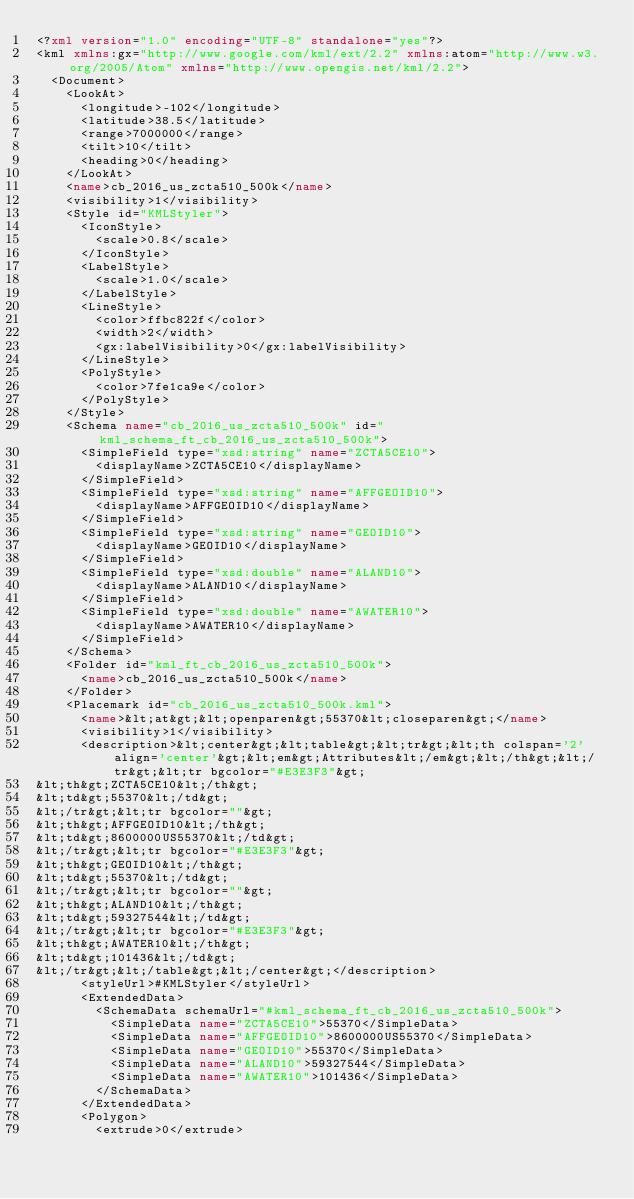<code> <loc_0><loc_0><loc_500><loc_500><_XML_><?xml version="1.0" encoding="UTF-8" standalone="yes"?>
<kml xmlns:gx="http://www.google.com/kml/ext/2.2" xmlns:atom="http://www.w3.org/2005/Atom" xmlns="http://www.opengis.net/kml/2.2">
  <Document>
    <LookAt>
      <longitude>-102</longitude>
      <latitude>38.5</latitude>
      <range>7000000</range>
      <tilt>10</tilt>
      <heading>0</heading>
    </LookAt>
    <name>cb_2016_us_zcta510_500k</name>
    <visibility>1</visibility>
    <Style id="KMLStyler">
      <IconStyle>
        <scale>0.8</scale>
      </IconStyle>
      <LabelStyle>
        <scale>1.0</scale>
      </LabelStyle>
      <LineStyle>
        <color>ffbc822f</color>
        <width>2</width>
        <gx:labelVisibility>0</gx:labelVisibility>
      </LineStyle>
      <PolyStyle>
        <color>7fe1ca9e</color>
      </PolyStyle>
    </Style>
    <Schema name="cb_2016_us_zcta510_500k" id="kml_schema_ft_cb_2016_us_zcta510_500k">
      <SimpleField type="xsd:string" name="ZCTA5CE10">
        <displayName>ZCTA5CE10</displayName>
      </SimpleField>
      <SimpleField type="xsd:string" name="AFFGEOID10">
        <displayName>AFFGEOID10</displayName>
      </SimpleField>
      <SimpleField type="xsd:string" name="GEOID10">
        <displayName>GEOID10</displayName>
      </SimpleField>
      <SimpleField type="xsd:double" name="ALAND10">
        <displayName>ALAND10</displayName>
      </SimpleField>
      <SimpleField type="xsd:double" name="AWATER10">
        <displayName>AWATER10</displayName>
      </SimpleField>
    </Schema>
    <Folder id="kml_ft_cb_2016_us_zcta510_500k">
      <name>cb_2016_us_zcta510_500k</name>
    </Folder>
    <Placemark id="cb_2016_us_zcta510_500k.kml">
      <name>&lt;at&gt;&lt;openparen&gt;55370&lt;closeparen&gt;</name>
      <visibility>1</visibility>
      <description>&lt;center&gt;&lt;table&gt;&lt;tr&gt;&lt;th colspan='2' align='center'&gt;&lt;em&gt;Attributes&lt;/em&gt;&lt;/th&gt;&lt;/tr&gt;&lt;tr bgcolor="#E3E3F3"&gt;
&lt;th&gt;ZCTA5CE10&lt;/th&gt;
&lt;td&gt;55370&lt;/td&gt;
&lt;/tr&gt;&lt;tr bgcolor=""&gt;
&lt;th&gt;AFFGEOID10&lt;/th&gt;
&lt;td&gt;8600000US55370&lt;/td&gt;
&lt;/tr&gt;&lt;tr bgcolor="#E3E3F3"&gt;
&lt;th&gt;GEOID10&lt;/th&gt;
&lt;td&gt;55370&lt;/td&gt;
&lt;/tr&gt;&lt;tr bgcolor=""&gt;
&lt;th&gt;ALAND10&lt;/th&gt;
&lt;td&gt;59327544&lt;/td&gt;
&lt;/tr&gt;&lt;tr bgcolor="#E3E3F3"&gt;
&lt;th&gt;AWATER10&lt;/th&gt;
&lt;td&gt;101436&lt;/td&gt;
&lt;/tr&gt;&lt;/table&gt;&lt;/center&gt;</description>
      <styleUrl>#KMLStyler</styleUrl>
      <ExtendedData>
        <SchemaData schemaUrl="#kml_schema_ft_cb_2016_us_zcta510_500k">
          <SimpleData name="ZCTA5CE10">55370</SimpleData>
          <SimpleData name="AFFGEOID10">8600000US55370</SimpleData>
          <SimpleData name="GEOID10">55370</SimpleData>
          <SimpleData name="ALAND10">59327544</SimpleData>
          <SimpleData name="AWATER10">101436</SimpleData>
        </SchemaData>
      </ExtendedData>
      <Polygon>
        <extrude>0</extrude></code> 